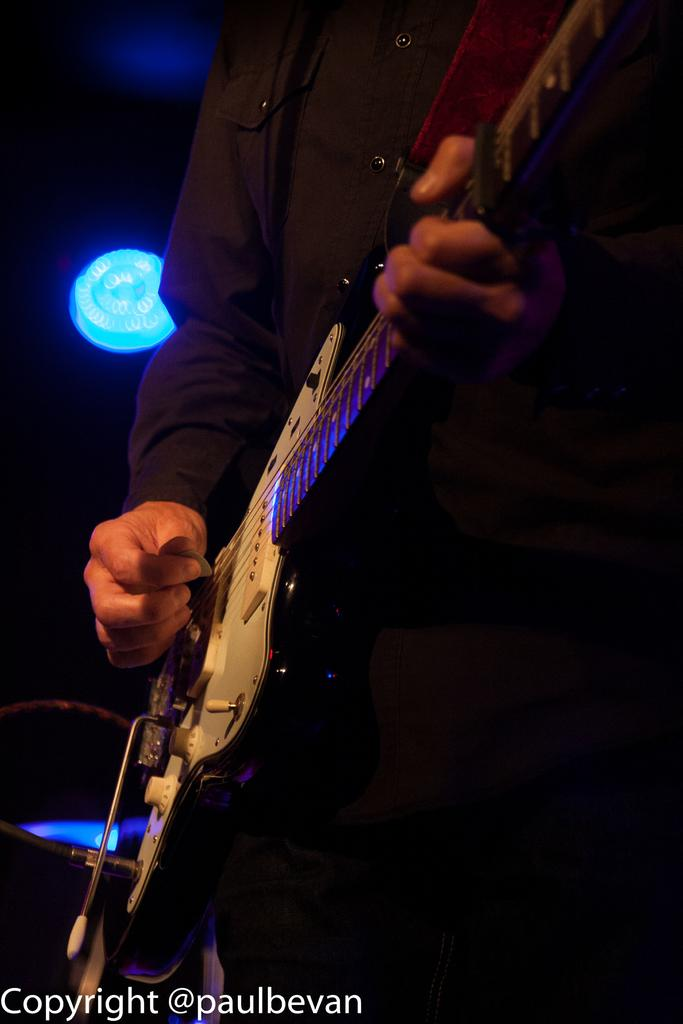What is the man in the image doing? The man is playing a guitar in the image. Can you describe the lighting in the image? There is a light on the ceiling in the image. How does the man feel about the comparison between his guitar skills and those of a famous musician? There is no information about the man's feelings or any comparison to a famous musician, so we cannot answer this question. 